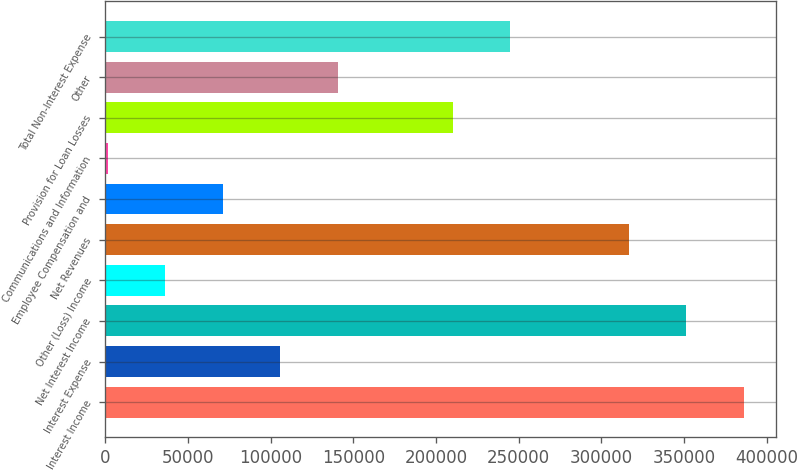<chart> <loc_0><loc_0><loc_500><loc_500><bar_chart><fcel>Interest Income<fcel>Interest Expense<fcel>Net Interest Income<fcel>Other (Loss) Income<fcel>Net Revenues<fcel>Employee Compensation and<fcel>Communications and Information<fcel>Provision for Loan Losses<fcel>Other<fcel>Total Non-Interest Expense<nl><fcel>386161<fcel>105819<fcel>351405<fcel>36307.8<fcel>316649<fcel>71063.6<fcel>1552<fcel>210087<fcel>140575<fcel>244843<nl></chart> 